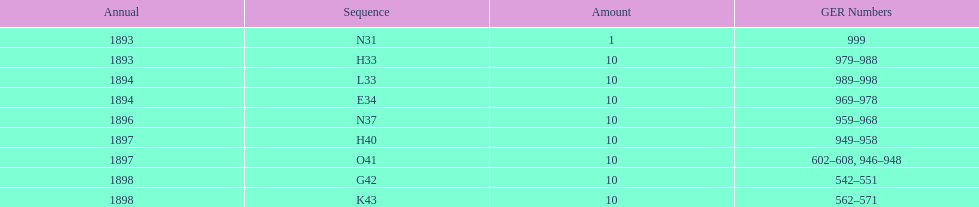How many years are listed? 5. 